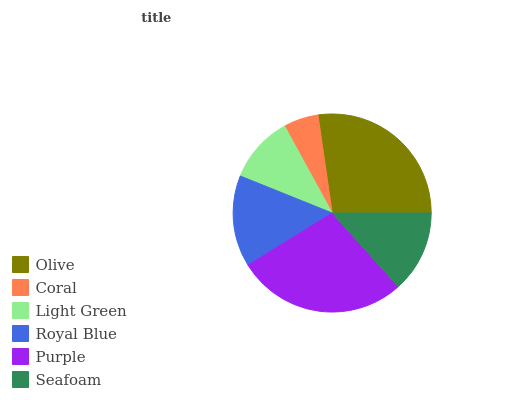Is Coral the minimum?
Answer yes or no. Yes. Is Purple the maximum?
Answer yes or no. Yes. Is Light Green the minimum?
Answer yes or no. No. Is Light Green the maximum?
Answer yes or no. No. Is Light Green greater than Coral?
Answer yes or no. Yes. Is Coral less than Light Green?
Answer yes or no. Yes. Is Coral greater than Light Green?
Answer yes or no. No. Is Light Green less than Coral?
Answer yes or no. No. Is Royal Blue the high median?
Answer yes or no. Yes. Is Seafoam the low median?
Answer yes or no. Yes. Is Seafoam the high median?
Answer yes or no. No. Is Purple the low median?
Answer yes or no. No. 